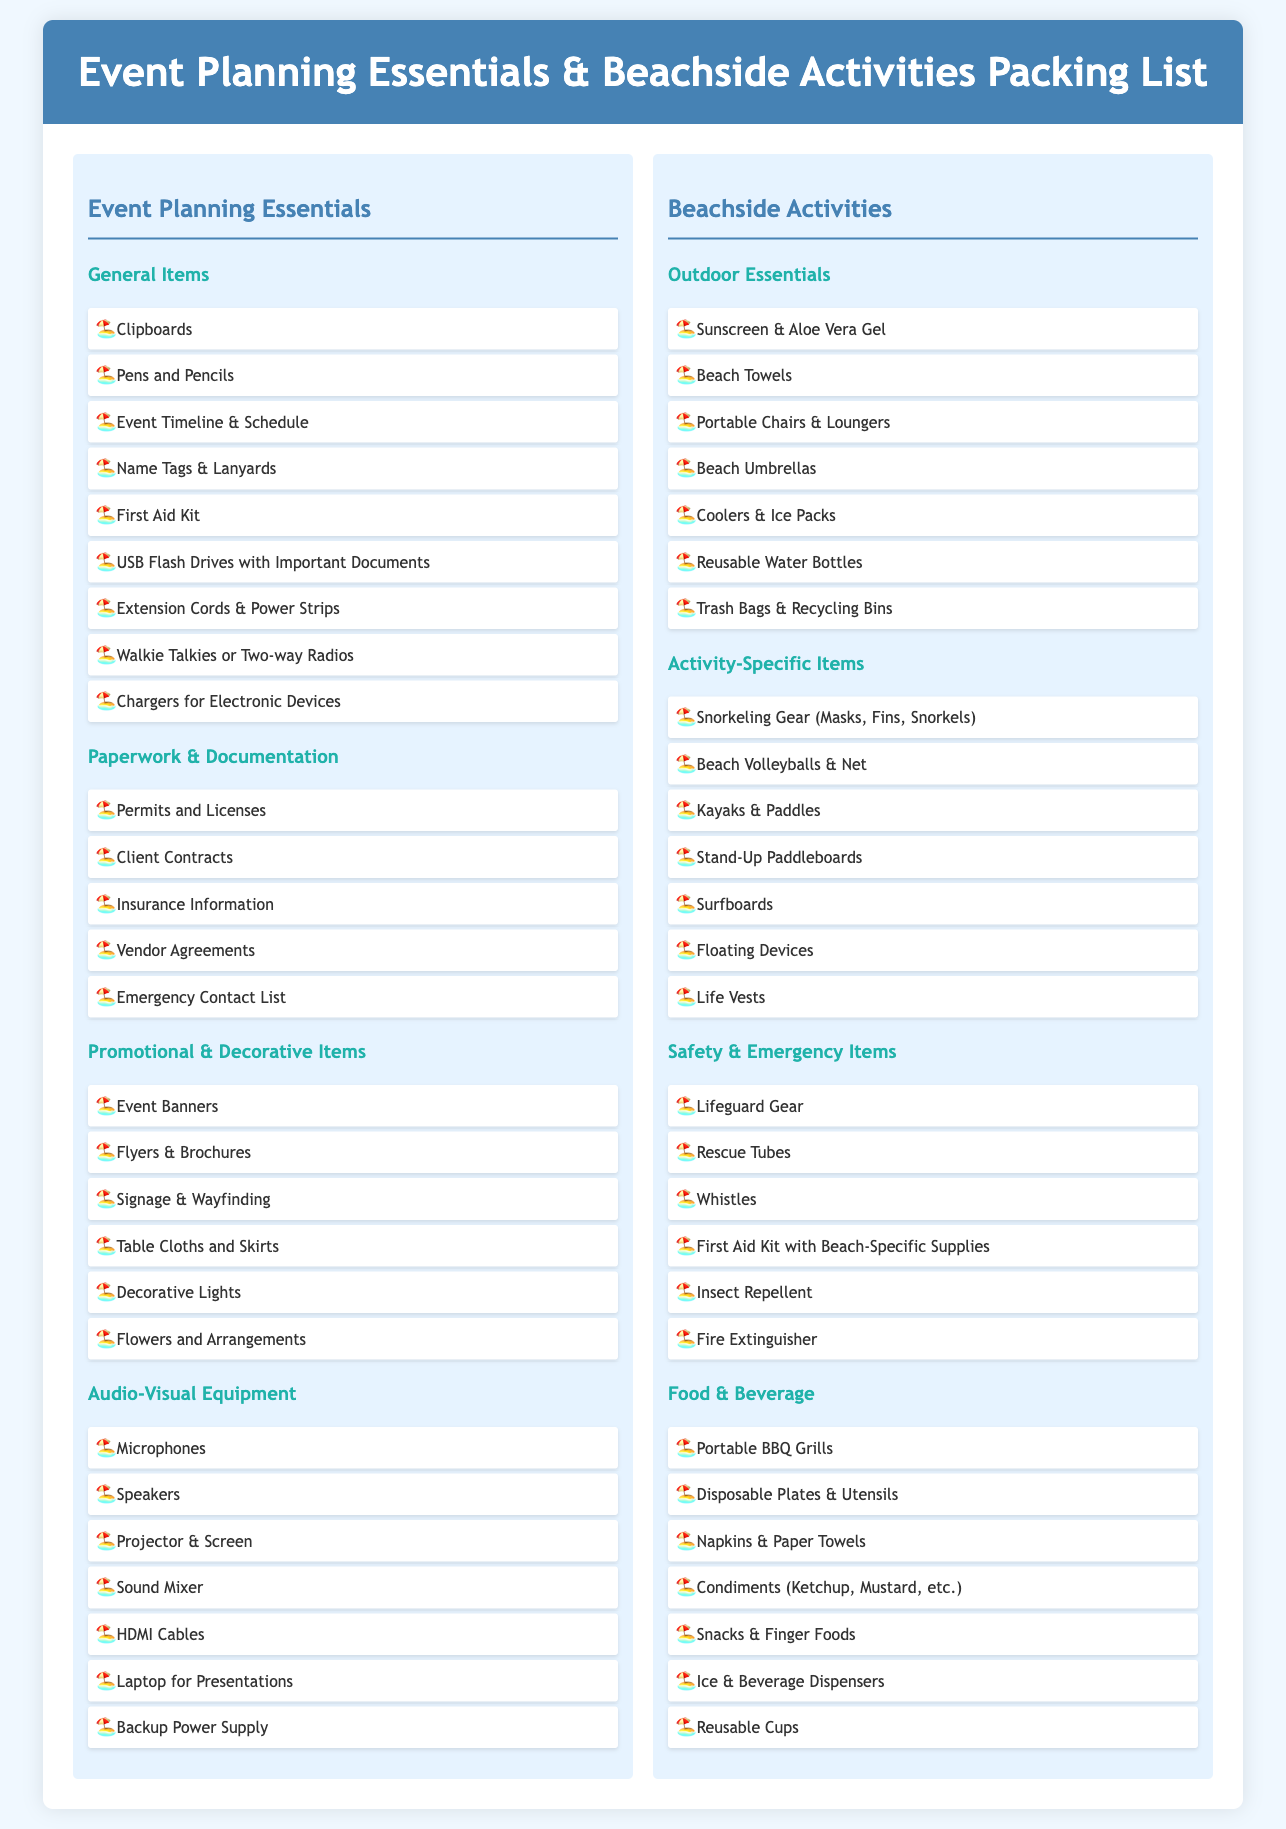what are the general items for event planning? The general items are listed under the Event Planning Essentials section, detailing necessary supplies for organizing events.
Answer: Clipboards, Pens and Pencils, Event Timeline & Schedule, Name Tags & Lanyards, First Aid Kit, USB Flash Drives with Important Documents, Extension Cords & Power Strips, Walkie Talkies or Two-way Radios, Chargers for Electronic Devices how many audio-visual equipment items are listed? The audio-visual equipment items can be counted in the respective section.
Answer: 7 what type of gear is required for snorkeling? This is found in the Activity-Specific Items under Beachside Activities.
Answer: Snorkeling Gear (Masks, Fins, Snorkels) which item is listed for safety and emergencies? This is found in the Safety & Emergency Items section, indicating what to have on hand in case of unforeseen issues.
Answer: Lifeguard Gear what are the beachside activity essentials for food and beverage? This is outlined in the Food & Beverage section, categorizing supplies related to refreshment at beachside activities.
Answer: Portable BBQ Grills, Disposable Plates & Utensils, Napkins & Paper Towels, Condiments (Ketchup, Mustard, etc.), Snacks & Finger Foods, Ice & Beverage Dispensers, Reusable Cups 